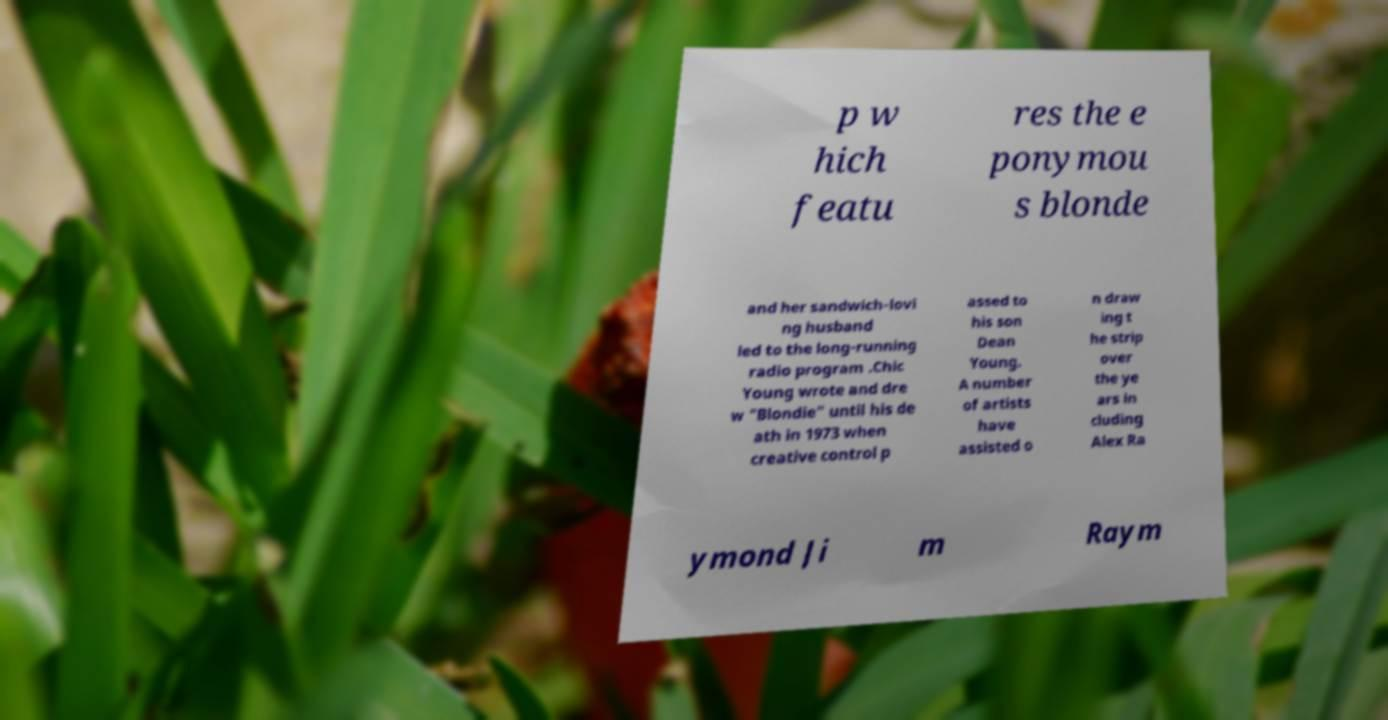Could you assist in decoding the text presented in this image and type it out clearly? p w hich featu res the e ponymou s blonde and her sandwich-lovi ng husband led to the long-running radio program .Chic Young wrote and dre w "Blondie" until his de ath in 1973 when creative control p assed to his son Dean Young. A number of artists have assisted o n draw ing t he strip over the ye ars in cluding Alex Ra ymond Ji m Raym 